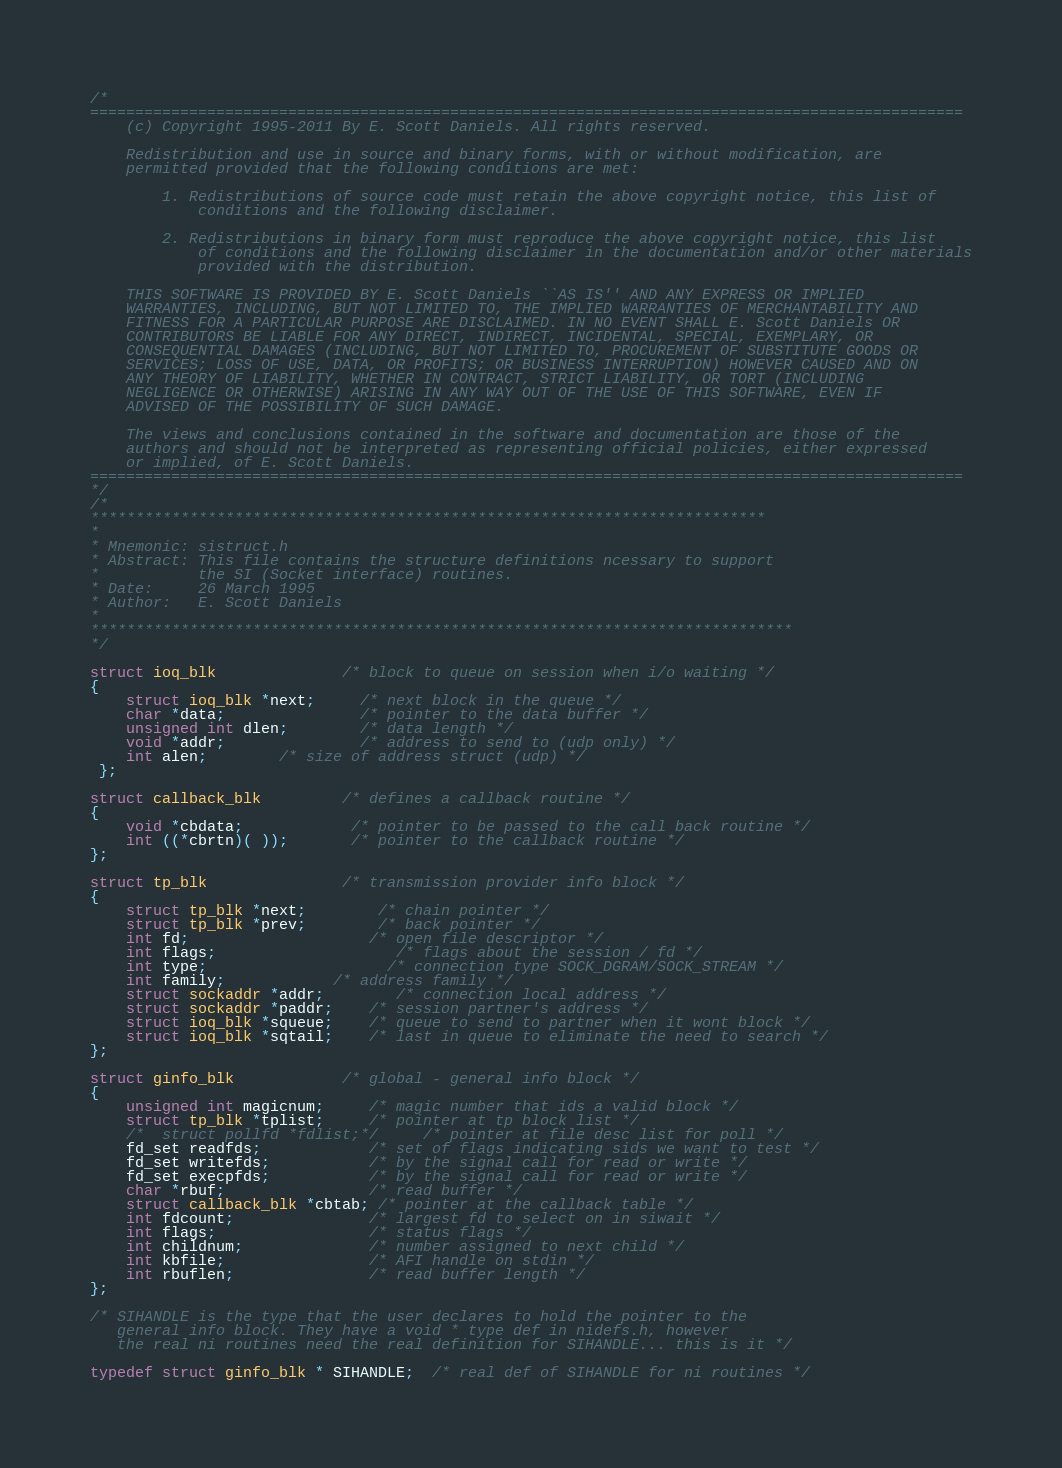<code> <loc_0><loc_0><loc_500><loc_500><_C_>/*
=================================================================================================
	(c) Copyright 1995-2011 By E. Scott Daniels. All rights reserved.

	Redistribution and use in source and binary forms, with or without modification, are
	permitted provided that the following conditions are met:
	
   		1. Redistributions of source code must retain the above copyright notice, this list of
      		conditions and the following disclaimer.
		
   		2. Redistributions in binary form must reproduce the above copyright notice, this list
      		of conditions and the following disclaimer in the documentation and/or other materials
      		provided with the distribution.
	
	THIS SOFTWARE IS PROVIDED BY E. Scott Daniels ``AS IS'' AND ANY EXPRESS OR IMPLIED
	WARRANTIES, INCLUDING, BUT NOT LIMITED TO, THE IMPLIED WARRANTIES OF MERCHANTABILITY AND
	FITNESS FOR A PARTICULAR PURPOSE ARE DISCLAIMED. IN NO EVENT SHALL E. Scott Daniels OR
	CONTRIBUTORS BE LIABLE FOR ANY DIRECT, INDIRECT, INCIDENTAL, SPECIAL, EXEMPLARY, OR
	CONSEQUENTIAL DAMAGES (INCLUDING, BUT NOT LIMITED TO, PROCUREMENT OF SUBSTITUTE GOODS OR
	SERVICES; LOSS OF USE, DATA, OR PROFITS; OR BUSINESS INTERRUPTION) HOWEVER CAUSED AND ON
	ANY THEORY OF LIABILITY, WHETHER IN CONTRACT, STRICT LIABILITY, OR TORT (INCLUDING
	NEGLIGENCE OR OTHERWISE) ARISING IN ANY WAY OUT OF THE USE OF THIS SOFTWARE, EVEN IF
	ADVISED OF THE POSSIBILITY OF SUCH DAMAGE.
	
	The views and conclusions contained in the software and documentation are those of the
	authors and should not be interpreted as representing official policies, either expressed
	or implied, of E. Scott Daniels.
=================================================================================================
*/
/*
***************************************************************************
*
* Mnemonic: sistruct.h
* Abstract: This file contains the structure definitions ncessary to support
*           the SI (Socket interface) routines.
* Date:     26 March 1995
* Author:   E. Scott Daniels
*
******************************************************************************
*/

struct ioq_blk              /* block to queue on session when i/o waiting */
{
	struct ioq_blk *next;     /* next block in the queue */
	char *data;               /* pointer to the data buffer */
	unsigned int dlen;        /* data length */
	void *addr;               /* address to send to (udp only) */
	int alen;		/* size of address struct (udp) */
 };

struct callback_blk         /* defines a callback routine */
{
	void *cbdata;            /* pointer to be passed to the call back routine */
	int ((*cbrtn)( ));       /* pointer to the callback routine */
};

struct tp_blk               /* transmission provider info block */
{
	struct tp_blk *next;      	/* chain pointer */
	struct tp_blk *prev;      	/* back pointer */
	int fd;                   	/* open file descriptor */
	int flags;                	/* flags about the session / fd */
	int type;                 	/* connection type SOCK_DGRAM/SOCK_STREAM */
	int family;			/* address family */
	struct sockaddr *addr; 		/* connection local address */
	struct sockaddr *paddr; 	/* session partner's address */
	struct ioq_blk *squeue;   	/* queue to send to partner when it wont block */
	struct ioq_blk *sqtail;   	/* last in queue to eliminate the need to search */
};

struct ginfo_blk            /* global - general info block */
{ 
	unsigned int magicnum;     /* magic number that ids a valid block */
	struct tp_blk *tplist;     /* pointer at tp block list */
	/*  struct pollfd *fdlist;*/     /* pointer at file desc list for poll */
	fd_set readfds;            /* set of flags indicating sids we want to test */
	fd_set writefds;           /* by the signal call for read or write */
	fd_set execpfds;           /* by the signal call for read or write */
	char *rbuf;                /* read buffer */
	struct callback_blk *cbtab; /* pointer at the callback table */
	int fdcount;               /* largest fd to select on in siwait */
	int flags;                 /* status flags */
	int childnum;              /* number assigned to next child */
	int kbfile;                /* AFI handle on stdin */
	int rbuflen;               /* read buffer length */
};

/* SIHANDLE is the type that the user declares to hold the pointer to the
   general info block. They have a void * type def in nidefs.h, however
   the real ni routines need the real definition for SIHANDLE... this is it */

typedef struct ginfo_blk * SIHANDLE;  /* real def of SIHANDLE for ni routines */
</code> 